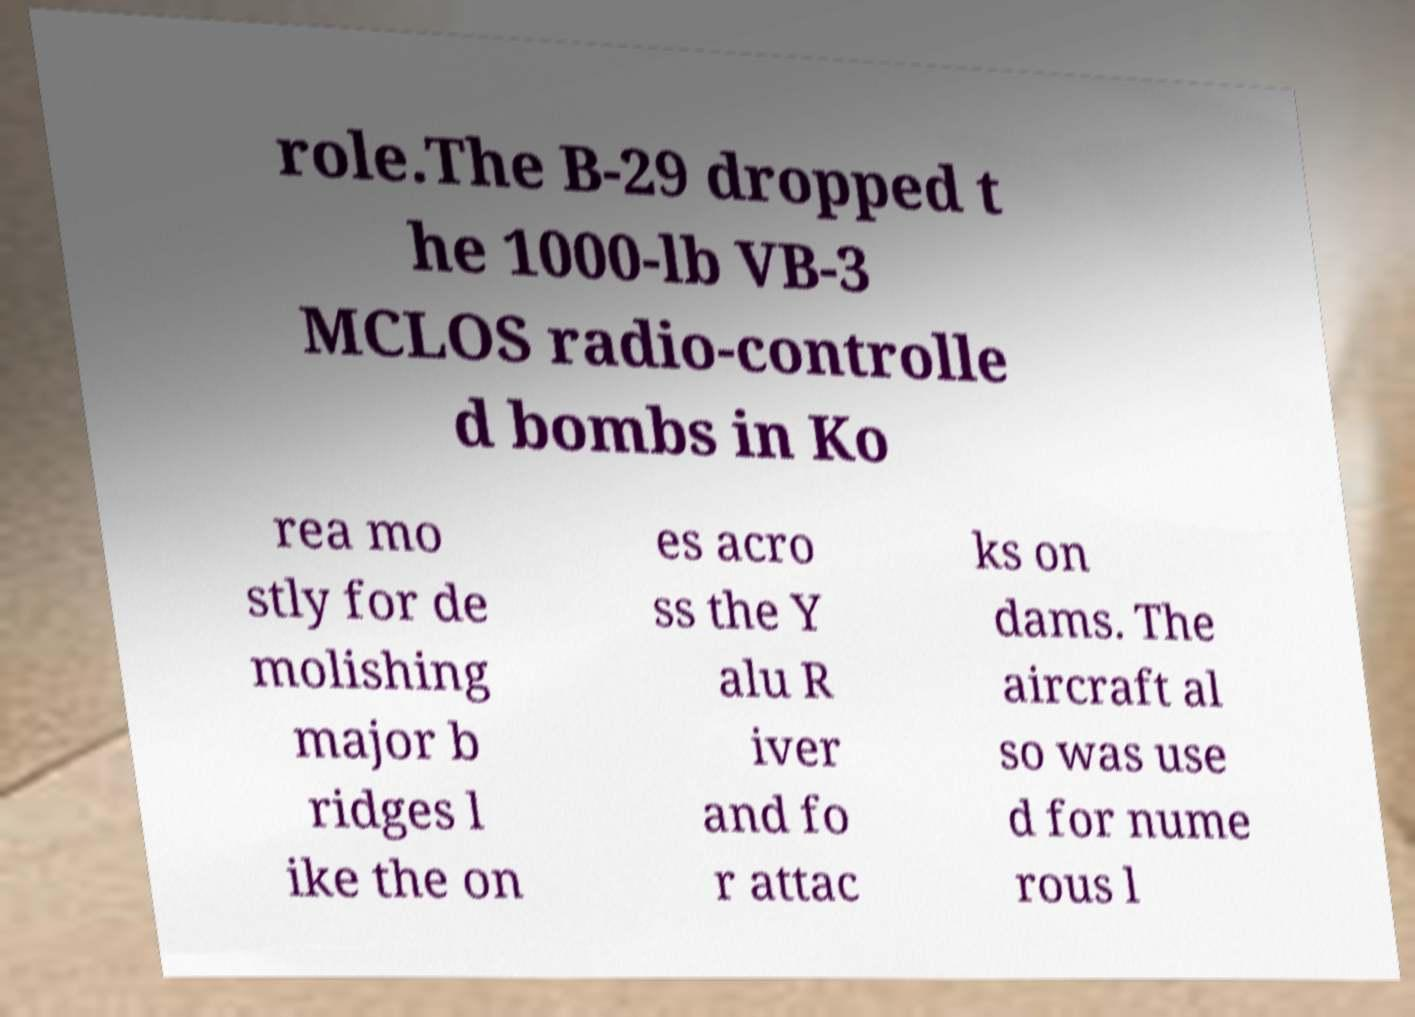For documentation purposes, I need the text within this image transcribed. Could you provide that? role.The B-29 dropped t he 1000-lb VB-3 MCLOS radio-controlle d bombs in Ko rea mo stly for de molishing major b ridges l ike the on es acro ss the Y alu R iver and fo r attac ks on dams. The aircraft al so was use d for nume rous l 